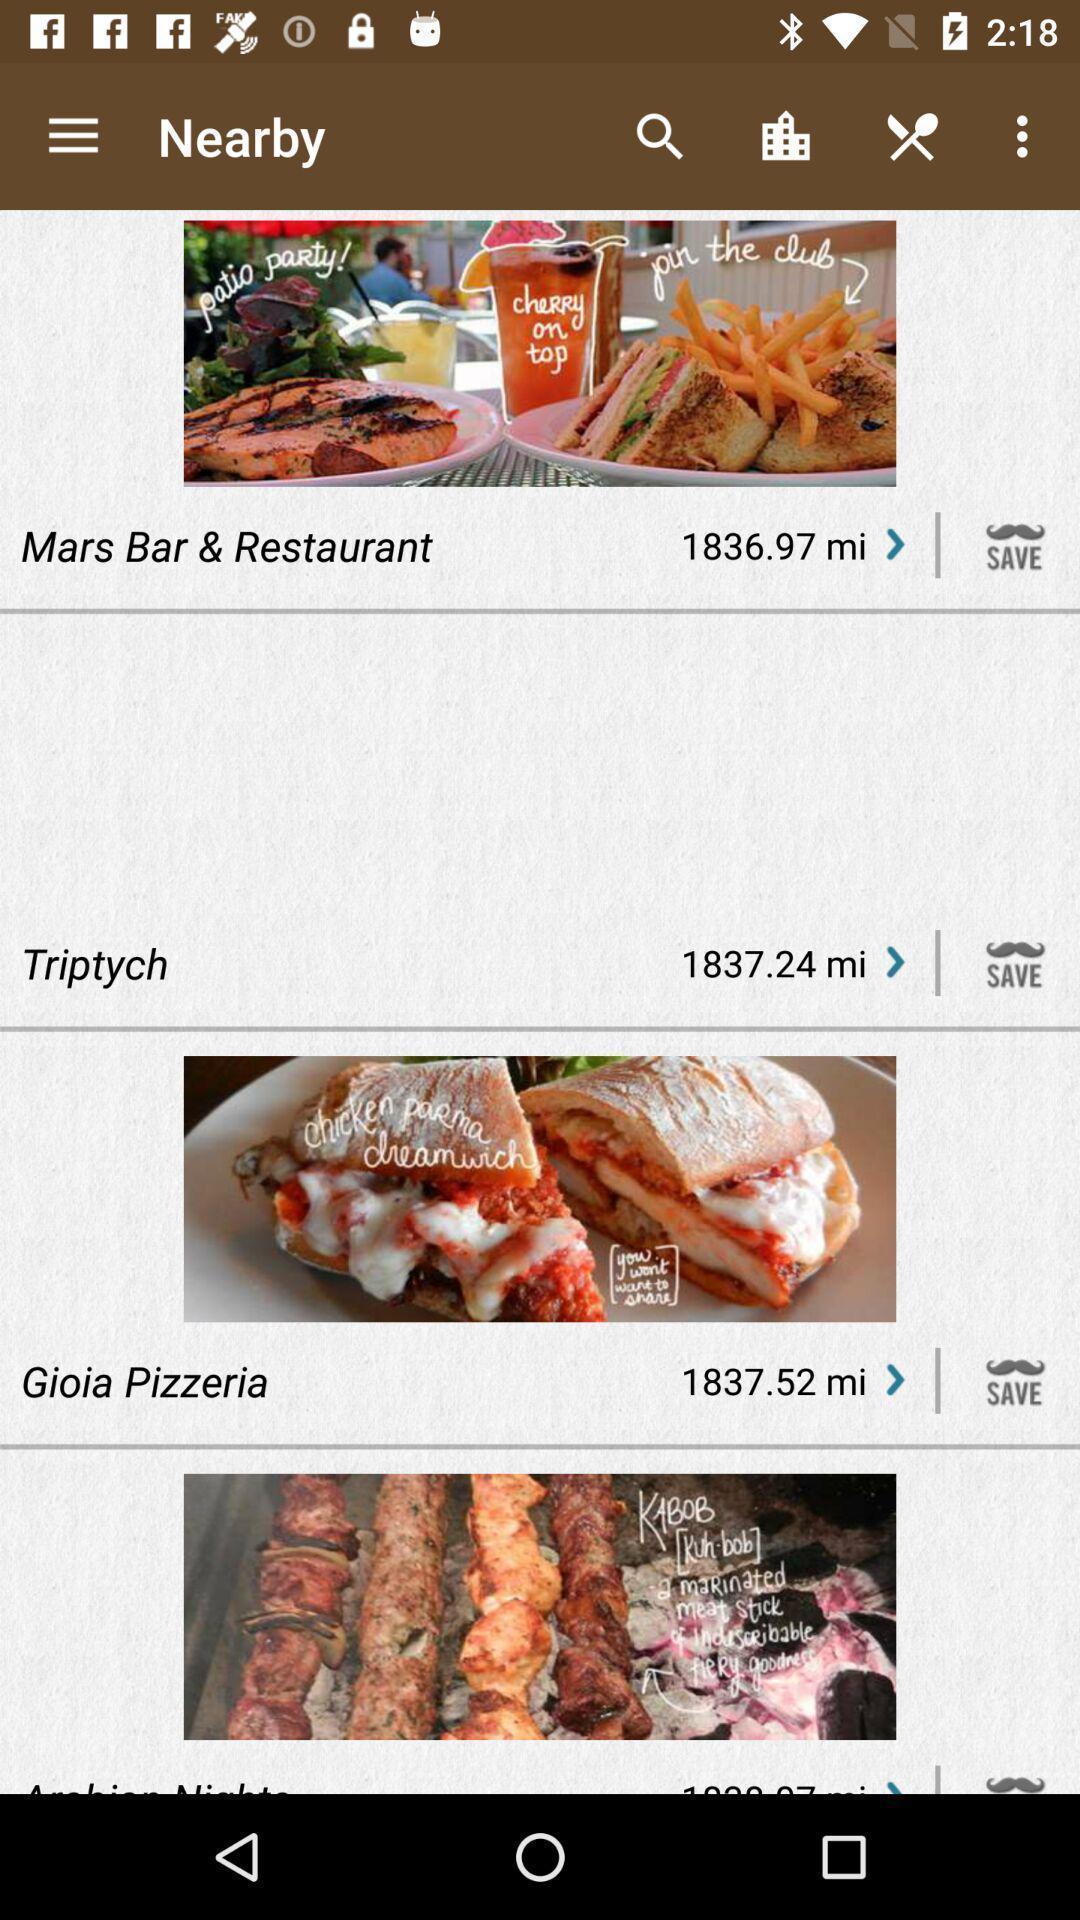What is the overall content of this screenshot? Screen showing nearby restaurants. 